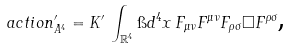Convert formula to latex. <formula><loc_0><loc_0><loc_500><loc_500>\ a c t i o n ^ { \prime } _ { A ^ { 4 } } = K ^ { \prime } \, \int _ { \mathbb { R } ^ { 4 } } \i d ^ { 4 } x \, F _ { \mu \nu } F ^ { \mu \nu } F _ { \rho \sigma } \Box F ^ { \rho \sigma } \text  ,</formula> 